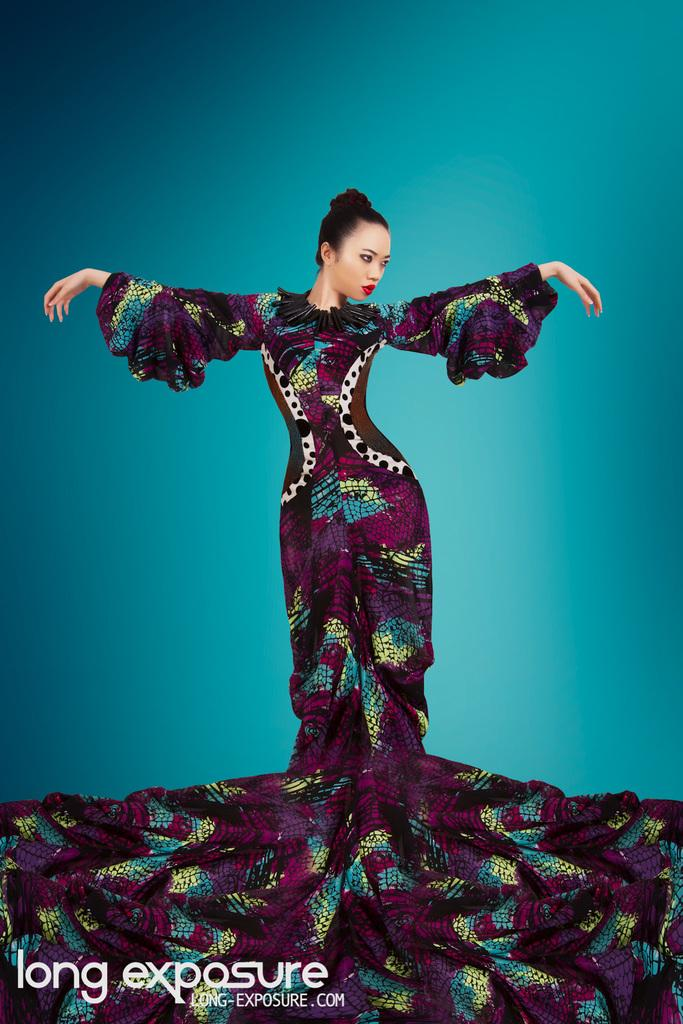Who is present in the image? There is a woman in the image. Can you describe any additional features of the image? There is a watermark in the image. How many pages are visible in the image? There is no reference to pages in the image, as it only features a woman and a watermark. 